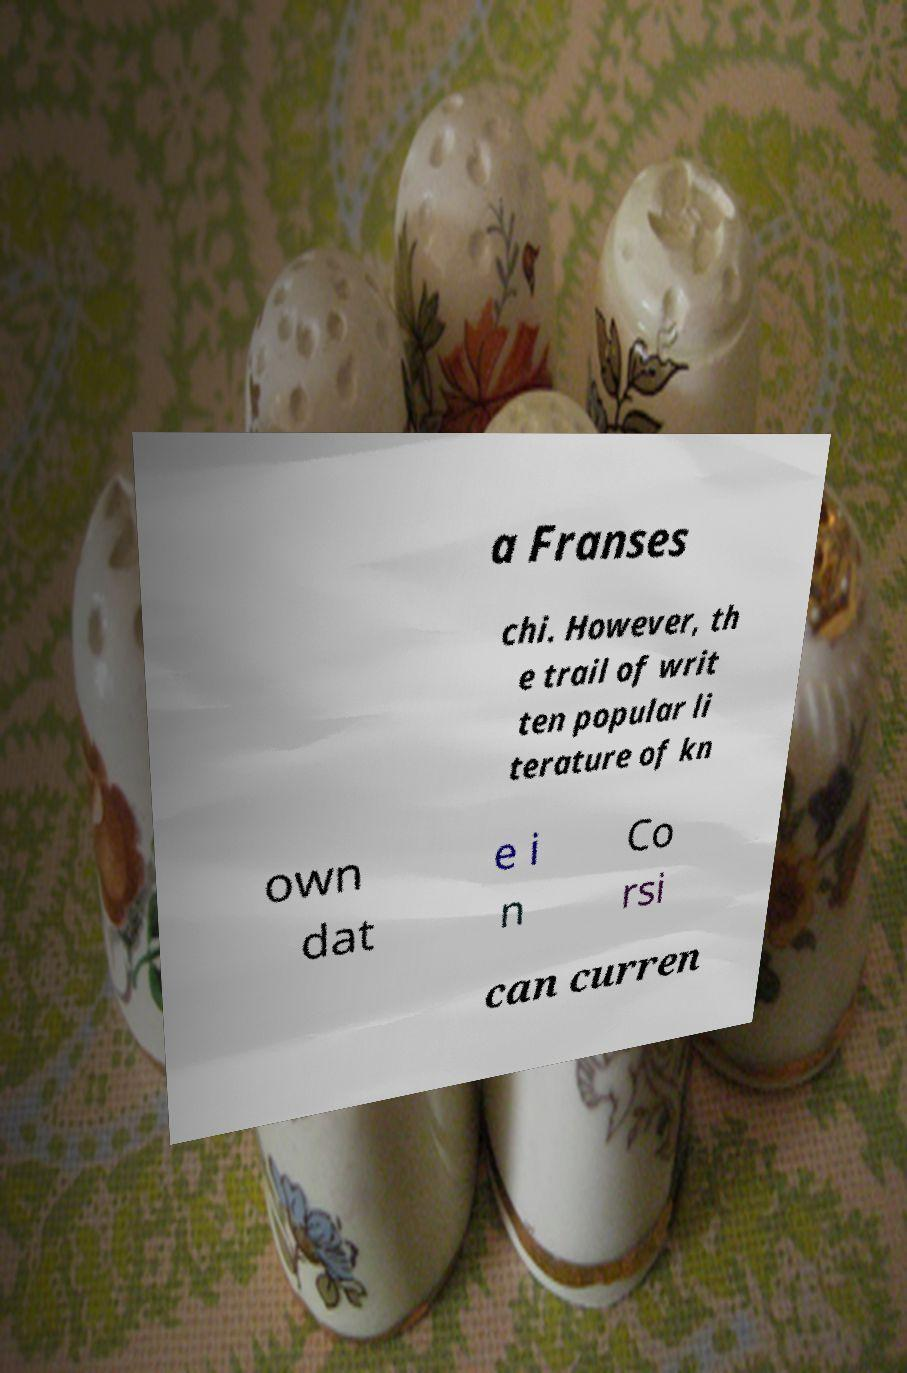Can you read and provide the text displayed in the image?This photo seems to have some interesting text. Can you extract and type it out for me? a Franses chi. However, th e trail of writ ten popular li terature of kn own dat e i n Co rsi can curren 